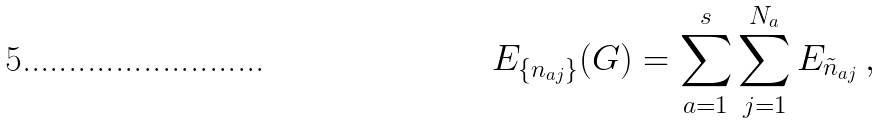Convert formula to latex. <formula><loc_0><loc_0><loc_500><loc_500>E _ { \{ n _ { a j } \} } ( G ) = \sum _ { a = 1 } ^ { s } \sum _ { j = 1 } ^ { N _ { a } } E _ { \tilde { n } _ { a j } } \, ,</formula> 